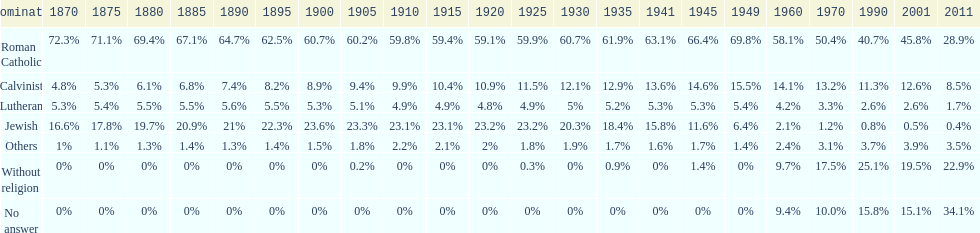Parse the full table. {'header': ['Denomination', '1870', '1875', '1880', '1885', '1890', '1895', '1900', '1905', '1910', '1915', '1920', '1925', '1930', '1935', '1941', '1945', '1949', '1960', '1970', '1990', '2001', '2011'], 'rows': [['Roman Catholic', '72.3%', '71.1%', '69.4%', '67.1%', '64.7%', '62.5%', '60.7%', '60.2%', '59.8%', '59.4%', '59.1%', '59.9%', '60.7%', '61.9%', '63.1%', '66.4%', '69.8%', '58.1%', '50.4%', '40.7%', '45.8%', '28.9%'], ['Calvinist', '4.8%', '5.3%', '6.1%', '6.8%', '7.4%', '8.2%', '8.9%', '9.4%', '9.9%', '10.4%', '10.9%', '11.5%', '12.1%', '12.9%', '13.6%', '14.6%', '15.5%', '14.1%', '13.2%', '11.3%', '12.6%', '8.5%'], ['Lutheran', '5.3%', '5.4%', '5.5%', '5.5%', '5.6%', '5.5%', '5.3%', '5.1%', '4.9%', '4.9%', '4.8%', '4.9%', '5%', '5.2%', '5.3%', '5.3%', '5.4%', '4.2%', '3.3%', '2.6%', '2.6%', '1.7%'], ['Jewish', '16.6%', '17.8%', '19.7%', '20.9%', '21%', '22.3%', '23.6%', '23.3%', '23.1%', '23.1%', '23.2%', '23.2%', '20.3%', '18.4%', '15.8%', '11.6%', '6.4%', '2.1%', '1.2%', '0.8%', '0.5%', '0.4%'], ['Others', '1%', '1.1%', '1.3%', '1.4%', '1.3%', '1.4%', '1.5%', '1.8%', '2.2%', '2.1%', '2%', '1.8%', '1.9%', '1.7%', '1.6%', '1.7%', '1.4%', '2.4%', '3.1%', '3.7%', '3.9%', '3.5%'], ['Without religion', '0%', '0%', '0%', '0%', '0%', '0%', '0%', '0.2%', '0%', '0%', '0%', '0.3%', '0%', '0.9%', '0%', '1.4%', '0%', '9.7%', '17.5%', '25.1%', '19.5%', '22.9%'], ['No answer', '0%', '0%', '0%', '0%', '0%', '0%', '0%', '0%', '0%', '0%', '0%', '0%', '0%', '0%', '0%', '0%', '0%', '9.4%', '10.0%', '15.8%', '15.1%', '34.1%']]} How many denominations never dropped below 20%? 1. 